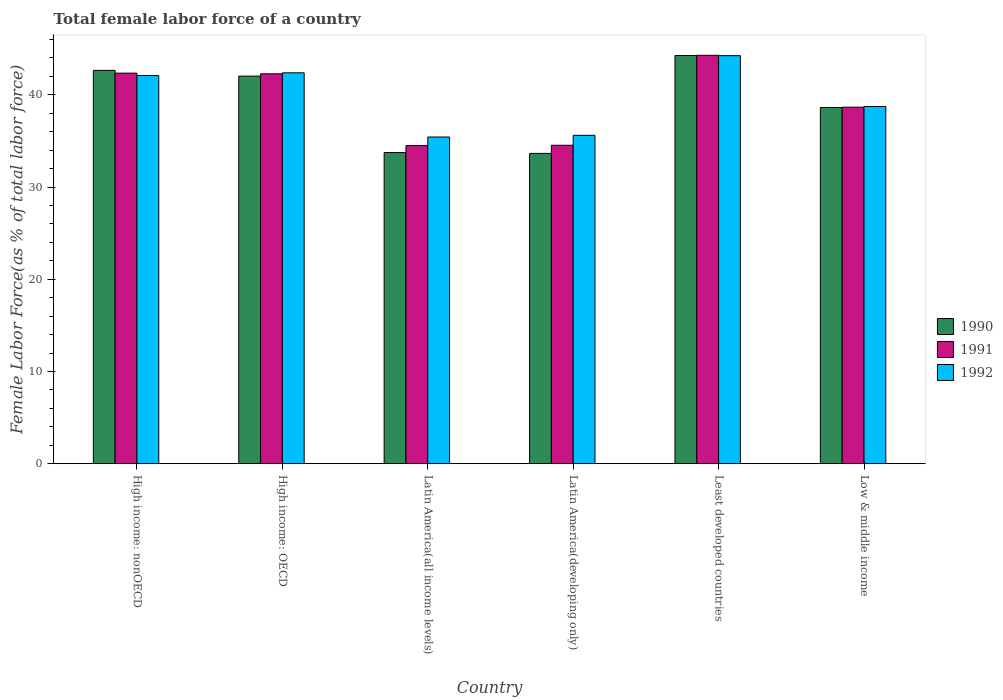How many different coloured bars are there?
Your answer should be compact. 3. Are the number of bars per tick equal to the number of legend labels?
Keep it short and to the point. Yes. Are the number of bars on each tick of the X-axis equal?
Keep it short and to the point. Yes. How many bars are there on the 2nd tick from the right?
Your answer should be very brief. 3. What is the label of the 1st group of bars from the left?
Ensure brevity in your answer.  High income: nonOECD. What is the percentage of female labor force in 1991 in Low & middle income?
Make the answer very short. 38.65. Across all countries, what is the maximum percentage of female labor force in 1990?
Offer a terse response. 44.25. Across all countries, what is the minimum percentage of female labor force in 1992?
Give a very brief answer. 35.42. In which country was the percentage of female labor force in 1990 maximum?
Ensure brevity in your answer.  Least developed countries. In which country was the percentage of female labor force in 1992 minimum?
Keep it short and to the point. Latin America(all income levels). What is the total percentage of female labor force in 1991 in the graph?
Ensure brevity in your answer.  236.56. What is the difference between the percentage of female labor force in 1992 in High income: OECD and that in Least developed countries?
Provide a succinct answer. -1.86. What is the difference between the percentage of female labor force in 1992 in High income: OECD and the percentage of female labor force in 1991 in Latin America(developing only)?
Ensure brevity in your answer.  7.85. What is the average percentage of female labor force in 1991 per country?
Offer a very short reply. 39.43. What is the difference between the percentage of female labor force of/in 1990 and percentage of female labor force of/in 1991 in Least developed countries?
Keep it short and to the point. -0.02. In how many countries, is the percentage of female labor force in 1990 greater than 10 %?
Give a very brief answer. 6. What is the ratio of the percentage of female labor force in 1991 in High income: OECD to that in High income: nonOECD?
Keep it short and to the point. 1. Is the difference between the percentage of female labor force in 1990 in Latin America(all income levels) and Least developed countries greater than the difference between the percentage of female labor force in 1991 in Latin America(all income levels) and Least developed countries?
Give a very brief answer. No. What is the difference between the highest and the second highest percentage of female labor force in 1991?
Give a very brief answer. -1.94. What is the difference between the highest and the lowest percentage of female labor force in 1990?
Provide a succinct answer. 10.61. Is the sum of the percentage of female labor force in 1992 in High income: OECD and High income: nonOECD greater than the maximum percentage of female labor force in 1990 across all countries?
Provide a succinct answer. Yes. What does the 1st bar from the left in Low & middle income represents?
Keep it short and to the point. 1990. Is it the case that in every country, the sum of the percentage of female labor force in 1991 and percentage of female labor force in 1992 is greater than the percentage of female labor force in 1990?
Your answer should be very brief. Yes. Are all the bars in the graph horizontal?
Make the answer very short. No. How many countries are there in the graph?
Ensure brevity in your answer.  6. Where does the legend appear in the graph?
Offer a terse response. Center right. How are the legend labels stacked?
Provide a succinct answer. Vertical. What is the title of the graph?
Your answer should be very brief. Total female labor force of a country. Does "1972" appear as one of the legend labels in the graph?
Make the answer very short. No. What is the label or title of the X-axis?
Make the answer very short. Country. What is the label or title of the Y-axis?
Keep it short and to the point. Female Labor Force(as % of total labor force). What is the Female Labor Force(as % of total labor force) in 1990 in High income: nonOECD?
Your answer should be very brief. 42.64. What is the Female Labor Force(as % of total labor force) of 1991 in High income: nonOECD?
Provide a short and direct response. 42.34. What is the Female Labor Force(as % of total labor force) of 1992 in High income: nonOECD?
Your answer should be very brief. 42.08. What is the Female Labor Force(as % of total labor force) in 1990 in High income: OECD?
Your response must be concise. 42.02. What is the Female Labor Force(as % of total labor force) of 1991 in High income: OECD?
Your answer should be compact. 42.27. What is the Female Labor Force(as % of total labor force) in 1992 in High income: OECD?
Your response must be concise. 42.38. What is the Female Labor Force(as % of total labor force) of 1990 in Latin America(all income levels)?
Make the answer very short. 33.73. What is the Female Labor Force(as % of total labor force) in 1991 in Latin America(all income levels)?
Your answer should be compact. 34.49. What is the Female Labor Force(as % of total labor force) of 1992 in Latin America(all income levels)?
Give a very brief answer. 35.42. What is the Female Labor Force(as % of total labor force) of 1990 in Latin America(developing only)?
Offer a terse response. 33.64. What is the Female Labor Force(as % of total labor force) of 1991 in Latin America(developing only)?
Provide a short and direct response. 34.52. What is the Female Labor Force(as % of total labor force) of 1992 in Latin America(developing only)?
Your answer should be very brief. 35.6. What is the Female Labor Force(as % of total labor force) of 1990 in Least developed countries?
Give a very brief answer. 44.25. What is the Female Labor Force(as % of total labor force) in 1991 in Least developed countries?
Offer a terse response. 44.28. What is the Female Labor Force(as % of total labor force) in 1992 in Least developed countries?
Give a very brief answer. 44.24. What is the Female Labor Force(as % of total labor force) in 1990 in Low & middle income?
Give a very brief answer. 38.62. What is the Female Labor Force(as % of total labor force) in 1991 in Low & middle income?
Offer a terse response. 38.65. What is the Female Labor Force(as % of total labor force) in 1992 in Low & middle income?
Ensure brevity in your answer.  38.73. Across all countries, what is the maximum Female Labor Force(as % of total labor force) in 1990?
Your answer should be very brief. 44.25. Across all countries, what is the maximum Female Labor Force(as % of total labor force) in 1991?
Keep it short and to the point. 44.28. Across all countries, what is the maximum Female Labor Force(as % of total labor force) in 1992?
Ensure brevity in your answer.  44.24. Across all countries, what is the minimum Female Labor Force(as % of total labor force) in 1990?
Offer a very short reply. 33.64. Across all countries, what is the minimum Female Labor Force(as % of total labor force) in 1991?
Offer a terse response. 34.49. Across all countries, what is the minimum Female Labor Force(as % of total labor force) of 1992?
Your answer should be very brief. 35.42. What is the total Female Labor Force(as % of total labor force) of 1990 in the graph?
Provide a succinct answer. 234.91. What is the total Female Labor Force(as % of total labor force) of 1991 in the graph?
Provide a short and direct response. 236.56. What is the total Female Labor Force(as % of total labor force) in 1992 in the graph?
Provide a succinct answer. 238.45. What is the difference between the Female Labor Force(as % of total labor force) of 1990 in High income: nonOECD and that in High income: OECD?
Provide a short and direct response. 0.62. What is the difference between the Female Labor Force(as % of total labor force) in 1991 in High income: nonOECD and that in High income: OECD?
Offer a terse response. 0.07. What is the difference between the Female Labor Force(as % of total labor force) in 1992 in High income: nonOECD and that in High income: OECD?
Make the answer very short. -0.29. What is the difference between the Female Labor Force(as % of total labor force) of 1990 in High income: nonOECD and that in Latin America(all income levels)?
Give a very brief answer. 8.91. What is the difference between the Female Labor Force(as % of total labor force) in 1991 in High income: nonOECD and that in Latin America(all income levels)?
Your response must be concise. 7.85. What is the difference between the Female Labor Force(as % of total labor force) of 1992 in High income: nonOECD and that in Latin America(all income levels)?
Ensure brevity in your answer.  6.66. What is the difference between the Female Labor Force(as % of total labor force) of 1990 in High income: nonOECD and that in Latin America(developing only)?
Provide a succinct answer. 9. What is the difference between the Female Labor Force(as % of total labor force) of 1991 in High income: nonOECD and that in Latin America(developing only)?
Ensure brevity in your answer.  7.82. What is the difference between the Female Labor Force(as % of total labor force) in 1992 in High income: nonOECD and that in Latin America(developing only)?
Offer a terse response. 6.48. What is the difference between the Female Labor Force(as % of total labor force) of 1990 in High income: nonOECD and that in Least developed countries?
Keep it short and to the point. -1.61. What is the difference between the Female Labor Force(as % of total labor force) in 1991 in High income: nonOECD and that in Least developed countries?
Offer a very short reply. -1.94. What is the difference between the Female Labor Force(as % of total labor force) of 1992 in High income: nonOECD and that in Least developed countries?
Offer a terse response. -2.16. What is the difference between the Female Labor Force(as % of total labor force) in 1990 in High income: nonOECD and that in Low & middle income?
Provide a short and direct response. 4.03. What is the difference between the Female Labor Force(as % of total labor force) of 1991 in High income: nonOECD and that in Low & middle income?
Your answer should be compact. 3.69. What is the difference between the Female Labor Force(as % of total labor force) in 1992 in High income: nonOECD and that in Low & middle income?
Your response must be concise. 3.35. What is the difference between the Female Labor Force(as % of total labor force) of 1990 in High income: OECD and that in Latin America(all income levels)?
Your answer should be very brief. 8.29. What is the difference between the Female Labor Force(as % of total labor force) in 1991 in High income: OECD and that in Latin America(all income levels)?
Offer a very short reply. 7.78. What is the difference between the Female Labor Force(as % of total labor force) in 1992 in High income: OECD and that in Latin America(all income levels)?
Give a very brief answer. 6.96. What is the difference between the Female Labor Force(as % of total labor force) of 1990 in High income: OECD and that in Latin America(developing only)?
Provide a succinct answer. 8.38. What is the difference between the Female Labor Force(as % of total labor force) of 1991 in High income: OECD and that in Latin America(developing only)?
Provide a succinct answer. 7.75. What is the difference between the Female Labor Force(as % of total labor force) of 1992 in High income: OECD and that in Latin America(developing only)?
Give a very brief answer. 6.77. What is the difference between the Female Labor Force(as % of total labor force) in 1990 in High income: OECD and that in Least developed countries?
Give a very brief answer. -2.23. What is the difference between the Female Labor Force(as % of total labor force) in 1991 in High income: OECD and that in Least developed countries?
Give a very brief answer. -2.01. What is the difference between the Female Labor Force(as % of total labor force) in 1992 in High income: OECD and that in Least developed countries?
Offer a very short reply. -1.86. What is the difference between the Female Labor Force(as % of total labor force) in 1990 in High income: OECD and that in Low & middle income?
Keep it short and to the point. 3.4. What is the difference between the Female Labor Force(as % of total labor force) in 1991 in High income: OECD and that in Low & middle income?
Provide a short and direct response. 3.62. What is the difference between the Female Labor Force(as % of total labor force) of 1992 in High income: OECD and that in Low & middle income?
Ensure brevity in your answer.  3.65. What is the difference between the Female Labor Force(as % of total labor force) in 1990 in Latin America(all income levels) and that in Latin America(developing only)?
Keep it short and to the point. 0.09. What is the difference between the Female Labor Force(as % of total labor force) of 1991 in Latin America(all income levels) and that in Latin America(developing only)?
Give a very brief answer. -0.03. What is the difference between the Female Labor Force(as % of total labor force) in 1992 in Latin America(all income levels) and that in Latin America(developing only)?
Offer a very short reply. -0.18. What is the difference between the Female Labor Force(as % of total labor force) in 1990 in Latin America(all income levels) and that in Least developed countries?
Ensure brevity in your answer.  -10.52. What is the difference between the Female Labor Force(as % of total labor force) of 1991 in Latin America(all income levels) and that in Least developed countries?
Make the answer very short. -9.79. What is the difference between the Female Labor Force(as % of total labor force) in 1992 in Latin America(all income levels) and that in Least developed countries?
Offer a terse response. -8.82. What is the difference between the Female Labor Force(as % of total labor force) of 1990 in Latin America(all income levels) and that in Low & middle income?
Provide a short and direct response. -4.88. What is the difference between the Female Labor Force(as % of total labor force) in 1991 in Latin America(all income levels) and that in Low & middle income?
Your answer should be compact. -4.16. What is the difference between the Female Labor Force(as % of total labor force) of 1992 in Latin America(all income levels) and that in Low & middle income?
Offer a very short reply. -3.31. What is the difference between the Female Labor Force(as % of total labor force) of 1990 in Latin America(developing only) and that in Least developed countries?
Ensure brevity in your answer.  -10.61. What is the difference between the Female Labor Force(as % of total labor force) of 1991 in Latin America(developing only) and that in Least developed countries?
Your response must be concise. -9.75. What is the difference between the Female Labor Force(as % of total labor force) in 1992 in Latin America(developing only) and that in Least developed countries?
Give a very brief answer. -8.63. What is the difference between the Female Labor Force(as % of total labor force) of 1990 in Latin America(developing only) and that in Low & middle income?
Your answer should be very brief. -4.97. What is the difference between the Female Labor Force(as % of total labor force) in 1991 in Latin America(developing only) and that in Low & middle income?
Offer a very short reply. -4.13. What is the difference between the Female Labor Force(as % of total labor force) of 1992 in Latin America(developing only) and that in Low & middle income?
Keep it short and to the point. -3.12. What is the difference between the Female Labor Force(as % of total labor force) in 1990 in Least developed countries and that in Low & middle income?
Provide a succinct answer. 5.64. What is the difference between the Female Labor Force(as % of total labor force) in 1991 in Least developed countries and that in Low & middle income?
Ensure brevity in your answer.  5.62. What is the difference between the Female Labor Force(as % of total labor force) in 1992 in Least developed countries and that in Low & middle income?
Your answer should be very brief. 5.51. What is the difference between the Female Labor Force(as % of total labor force) in 1990 in High income: nonOECD and the Female Labor Force(as % of total labor force) in 1991 in High income: OECD?
Your response must be concise. 0.37. What is the difference between the Female Labor Force(as % of total labor force) in 1990 in High income: nonOECD and the Female Labor Force(as % of total labor force) in 1992 in High income: OECD?
Your answer should be compact. 0.27. What is the difference between the Female Labor Force(as % of total labor force) of 1991 in High income: nonOECD and the Female Labor Force(as % of total labor force) of 1992 in High income: OECD?
Give a very brief answer. -0.04. What is the difference between the Female Labor Force(as % of total labor force) in 1990 in High income: nonOECD and the Female Labor Force(as % of total labor force) in 1991 in Latin America(all income levels)?
Your answer should be very brief. 8.15. What is the difference between the Female Labor Force(as % of total labor force) of 1990 in High income: nonOECD and the Female Labor Force(as % of total labor force) of 1992 in Latin America(all income levels)?
Provide a succinct answer. 7.22. What is the difference between the Female Labor Force(as % of total labor force) in 1991 in High income: nonOECD and the Female Labor Force(as % of total labor force) in 1992 in Latin America(all income levels)?
Offer a very short reply. 6.92. What is the difference between the Female Labor Force(as % of total labor force) in 1990 in High income: nonOECD and the Female Labor Force(as % of total labor force) in 1991 in Latin America(developing only)?
Your response must be concise. 8.12. What is the difference between the Female Labor Force(as % of total labor force) of 1990 in High income: nonOECD and the Female Labor Force(as % of total labor force) of 1992 in Latin America(developing only)?
Your response must be concise. 7.04. What is the difference between the Female Labor Force(as % of total labor force) in 1991 in High income: nonOECD and the Female Labor Force(as % of total labor force) in 1992 in Latin America(developing only)?
Offer a terse response. 6.74. What is the difference between the Female Labor Force(as % of total labor force) in 1990 in High income: nonOECD and the Female Labor Force(as % of total labor force) in 1991 in Least developed countries?
Your response must be concise. -1.63. What is the difference between the Female Labor Force(as % of total labor force) in 1990 in High income: nonOECD and the Female Labor Force(as % of total labor force) in 1992 in Least developed countries?
Ensure brevity in your answer.  -1.6. What is the difference between the Female Labor Force(as % of total labor force) in 1991 in High income: nonOECD and the Female Labor Force(as % of total labor force) in 1992 in Least developed countries?
Your answer should be very brief. -1.9. What is the difference between the Female Labor Force(as % of total labor force) of 1990 in High income: nonOECD and the Female Labor Force(as % of total labor force) of 1991 in Low & middle income?
Ensure brevity in your answer.  3.99. What is the difference between the Female Labor Force(as % of total labor force) of 1990 in High income: nonOECD and the Female Labor Force(as % of total labor force) of 1992 in Low & middle income?
Provide a succinct answer. 3.91. What is the difference between the Female Labor Force(as % of total labor force) in 1991 in High income: nonOECD and the Female Labor Force(as % of total labor force) in 1992 in Low & middle income?
Your response must be concise. 3.61. What is the difference between the Female Labor Force(as % of total labor force) of 1990 in High income: OECD and the Female Labor Force(as % of total labor force) of 1991 in Latin America(all income levels)?
Your answer should be very brief. 7.53. What is the difference between the Female Labor Force(as % of total labor force) of 1990 in High income: OECD and the Female Labor Force(as % of total labor force) of 1992 in Latin America(all income levels)?
Ensure brevity in your answer.  6.6. What is the difference between the Female Labor Force(as % of total labor force) of 1991 in High income: OECD and the Female Labor Force(as % of total labor force) of 1992 in Latin America(all income levels)?
Offer a terse response. 6.85. What is the difference between the Female Labor Force(as % of total labor force) in 1990 in High income: OECD and the Female Labor Force(as % of total labor force) in 1991 in Latin America(developing only)?
Provide a short and direct response. 7.5. What is the difference between the Female Labor Force(as % of total labor force) in 1990 in High income: OECD and the Female Labor Force(as % of total labor force) in 1992 in Latin America(developing only)?
Provide a succinct answer. 6.42. What is the difference between the Female Labor Force(as % of total labor force) of 1991 in High income: OECD and the Female Labor Force(as % of total labor force) of 1992 in Latin America(developing only)?
Keep it short and to the point. 6.67. What is the difference between the Female Labor Force(as % of total labor force) in 1990 in High income: OECD and the Female Labor Force(as % of total labor force) in 1991 in Least developed countries?
Make the answer very short. -2.26. What is the difference between the Female Labor Force(as % of total labor force) of 1990 in High income: OECD and the Female Labor Force(as % of total labor force) of 1992 in Least developed countries?
Your answer should be compact. -2.22. What is the difference between the Female Labor Force(as % of total labor force) in 1991 in High income: OECD and the Female Labor Force(as % of total labor force) in 1992 in Least developed countries?
Your answer should be compact. -1.97. What is the difference between the Female Labor Force(as % of total labor force) in 1990 in High income: OECD and the Female Labor Force(as % of total labor force) in 1991 in Low & middle income?
Offer a terse response. 3.37. What is the difference between the Female Labor Force(as % of total labor force) of 1990 in High income: OECD and the Female Labor Force(as % of total labor force) of 1992 in Low & middle income?
Your response must be concise. 3.29. What is the difference between the Female Labor Force(as % of total labor force) of 1991 in High income: OECD and the Female Labor Force(as % of total labor force) of 1992 in Low & middle income?
Provide a short and direct response. 3.54. What is the difference between the Female Labor Force(as % of total labor force) of 1990 in Latin America(all income levels) and the Female Labor Force(as % of total labor force) of 1991 in Latin America(developing only)?
Offer a very short reply. -0.79. What is the difference between the Female Labor Force(as % of total labor force) of 1990 in Latin America(all income levels) and the Female Labor Force(as % of total labor force) of 1992 in Latin America(developing only)?
Ensure brevity in your answer.  -1.87. What is the difference between the Female Labor Force(as % of total labor force) in 1991 in Latin America(all income levels) and the Female Labor Force(as % of total labor force) in 1992 in Latin America(developing only)?
Your answer should be very brief. -1.11. What is the difference between the Female Labor Force(as % of total labor force) of 1990 in Latin America(all income levels) and the Female Labor Force(as % of total labor force) of 1991 in Least developed countries?
Ensure brevity in your answer.  -10.55. What is the difference between the Female Labor Force(as % of total labor force) in 1990 in Latin America(all income levels) and the Female Labor Force(as % of total labor force) in 1992 in Least developed countries?
Your answer should be compact. -10.51. What is the difference between the Female Labor Force(as % of total labor force) in 1991 in Latin America(all income levels) and the Female Labor Force(as % of total labor force) in 1992 in Least developed countries?
Give a very brief answer. -9.75. What is the difference between the Female Labor Force(as % of total labor force) in 1990 in Latin America(all income levels) and the Female Labor Force(as % of total labor force) in 1991 in Low & middle income?
Keep it short and to the point. -4.92. What is the difference between the Female Labor Force(as % of total labor force) in 1990 in Latin America(all income levels) and the Female Labor Force(as % of total labor force) in 1992 in Low & middle income?
Offer a terse response. -5. What is the difference between the Female Labor Force(as % of total labor force) in 1991 in Latin America(all income levels) and the Female Labor Force(as % of total labor force) in 1992 in Low & middle income?
Your answer should be compact. -4.24. What is the difference between the Female Labor Force(as % of total labor force) in 1990 in Latin America(developing only) and the Female Labor Force(as % of total labor force) in 1991 in Least developed countries?
Make the answer very short. -10.63. What is the difference between the Female Labor Force(as % of total labor force) of 1990 in Latin America(developing only) and the Female Labor Force(as % of total labor force) of 1992 in Least developed countries?
Your response must be concise. -10.6. What is the difference between the Female Labor Force(as % of total labor force) in 1991 in Latin America(developing only) and the Female Labor Force(as % of total labor force) in 1992 in Least developed countries?
Make the answer very short. -9.72. What is the difference between the Female Labor Force(as % of total labor force) in 1990 in Latin America(developing only) and the Female Labor Force(as % of total labor force) in 1991 in Low & middle income?
Your answer should be very brief. -5.01. What is the difference between the Female Labor Force(as % of total labor force) of 1990 in Latin America(developing only) and the Female Labor Force(as % of total labor force) of 1992 in Low & middle income?
Keep it short and to the point. -5.09. What is the difference between the Female Labor Force(as % of total labor force) of 1991 in Latin America(developing only) and the Female Labor Force(as % of total labor force) of 1992 in Low & middle income?
Ensure brevity in your answer.  -4.21. What is the difference between the Female Labor Force(as % of total labor force) in 1990 in Least developed countries and the Female Labor Force(as % of total labor force) in 1991 in Low & middle income?
Offer a terse response. 5.6. What is the difference between the Female Labor Force(as % of total labor force) in 1990 in Least developed countries and the Female Labor Force(as % of total labor force) in 1992 in Low & middle income?
Your answer should be very brief. 5.53. What is the difference between the Female Labor Force(as % of total labor force) of 1991 in Least developed countries and the Female Labor Force(as % of total labor force) of 1992 in Low & middle income?
Your answer should be compact. 5.55. What is the average Female Labor Force(as % of total labor force) in 1990 per country?
Give a very brief answer. 39.15. What is the average Female Labor Force(as % of total labor force) of 1991 per country?
Your answer should be compact. 39.43. What is the average Female Labor Force(as % of total labor force) of 1992 per country?
Make the answer very short. 39.74. What is the difference between the Female Labor Force(as % of total labor force) of 1990 and Female Labor Force(as % of total labor force) of 1991 in High income: nonOECD?
Keep it short and to the point. 0.3. What is the difference between the Female Labor Force(as % of total labor force) in 1990 and Female Labor Force(as % of total labor force) in 1992 in High income: nonOECD?
Ensure brevity in your answer.  0.56. What is the difference between the Female Labor Force(as % of total labor force) of 1991 and Female Labor Force(as % of total labor force) of 1992 in High income: nonOECD?
Keep it short and to the point. 0.26. What is the difference between the Female Labor Force(as % of total labor force) in 1990 and Female Labor Force(as % of total labor force) in 1991 in High income: OECD?
Offer a very short reply. -0.25. What is the difference between the Female Labor Force(as % of total labor force) of 1990 and Female Labor Force(as % of total labor force) of 1992 in High income: OECD?
Offer a terse response. -0.36. What is the difference between the Female Labor Force(as % of total labor force) of 1991 and Female Labor Force(as % of total labor force) of 1992 in High income: OECD?
Give a very brief answer. -0.11. What is the difference between the Female Labor Force(as % of total labor force) of 1990 and Female Labor Force(as % of total labor force) of 1991 in Latin America(all income levels)?
Your response must be concise. -0.76. What is the difference between the Female Labor Force(as % of total labor force) in 1990 and Female Labor Force(as % of total labor force) in 1992 in Latin America(all income levels)?
Offer a very short reply. -1.69. What is the difference between the Female Labor Force(as % of total labor force) of 1991 and Female Labor Force(as % of total labor force) of 1992 in Latin America(all income levels)?
Provide a succinct answer. -0.93. What is the difference between the Female Labor Force(as % of total labor force) in 1990 and Female Labor Force(as % of total labor force) in 1991 in Latin America(developing only)?
Give a very brief answer. -0.88. What is the difference between the Female Labor Force(as % of total labor force) in 1990 and Female Labor Force(as % of total labor force) in 1992 in Latin America(developing only)?
Your answer should be compact. -1.96. What is the difference between the Female Labor Force(as % of total labor force) in 1991 and Female Labor Force(as % of total labor force) in 1992 in Latin America(developing only)?
Ensure brevity in your answer.  -1.08. What is the difference between the Female Labor Force(as % of total labor force) in 1990 and Female Labor Force(as % of total labor force) in 1991 in Least developed countries?
Make the answer very short. -0.02. What is the difference between the Female Labor Force(as % of total labor force) in 1990 and Female Labor Force(as % of total labor force) in 1992 in Least developed countries?
Offer a terse response. 0.01. What is the difference between the Female Labor Force(as % of total labor force) in 1991 and Female Labor Force(as % of total labor force) in 1992 in Least developed countries?
Offer a terse response. 0.04. What is the difference between the Female Labor Force(as % of total labor force) of 1990 and Female Labor Force(as % of total labor force) of 1991 in Low & middle income?
Your response must be concise. -0.04. What is the difference between the Female Labor Force(as % of total labor force) in 1990 and Female Labor Force(as % of total labor force) in 1992 in Low & middle income?
Offer a terse response. -0.11. What is the difference between the Female Labor Force(as % of total labor force) in 1991 and Female Labor Force(as % of total labor force) in 1992 in Low & middle income?
Your response must be concise. -0.07. What is the ratio of the Female Labor Force(as % of total labor force) in 1990 in High income: nonOECD to that in High income: OECD?
Your response must be concise. 1.01. What is the ratio of the Female Labor Force(as % of total labor force) in 1992 in High income: nonOECD to that in High income: OECD?
Offer a terse response. 0.99. What is the ratio of the Female Labor Force(as % of total labor force) in 1990 in High income: nonOECD to that in Latin America(all income levels)?
Provide a succinct answer. 1.26. What is the ratio of the Female Labor Force(as % of total labor force) in 1991 in High income: nonOECD to that in Latin America(all income levels)?
Make the answer very short. 1.23. What is the ratio of the Female Labor Force(as % of total labor force) in 1992 in High income: nonOECD to that in Latin America(all income levels)?
Offer a very short reply. 1.19. What is the ratio of the Female Labor Force(as % of total labor force) in 1990 in High income: nonOECD to that in Latin America(developing only)?
Your answer should be compact. 1.27. What is the ratio of the Female Labor Force(as % of total labor force) of 1991 in High income: nonOECD to that in Latin America(developing only)?
Your response must be concise. 1.23. What is the ratio of the Female Labor Force(as % of total labor force) in 1992 in High income: nonOECD to that in Latin America(developing only)?
Provide a succinct answer. 1.18. What is the ratio of the Female Labor Force(as % of total labor force) of 1990 in High income: nonOECD to that in Least developed countries?
Keep it short and to the point. 0.96. What is the ratio of the Female Labor Force(as % of total labor force) of 1991 in High income: nonOECD to that in Least developed countries?
Ensure brevity in your answer.  0.96. What is the ratio of the Female Labor Force(as % of total labor force) in 1992 in High income: nonOECD to that in Least developed countries?
Provide a succinct answer. 0.95. What is the ratio of the Female Labor Force(as % of total labor force) of 1990 in High income: nonOECD to that in Low & middle income?
Your response must be concise. 1.1. What is the ratio of the Female Labor Force(as % of total labor force) in 1991 in High income: nonOECD to that in Low & middle income?
Provide a short and direct response. 1.1. What is the ratio of the Female Labor Force(as % of total labor force) of 1992 in High income: nonOECD to that in Low & middle income?
Offer a very short reply. 1.09. What is the ratio of the Female Labor Force(as % of total labor force) of 1990 in High income: OECD to that in Latin America(all income levels)?
Offer a very short reply. 1.25. What is the ratio of the Female Labor Force(as % of total labor force) of 1991 in High income: OECD to that in Latin America(all income levels)?
Give a very brief answer. 1.23. What is the ratio of the Female Labor Force(as % of total labor force) in 1992 in High income: OECD to that in Latin America(all income levels)?
Your answer should be compact. 1.2. What is the ratio of the Female Labor Force(as % of total labor force) of 1990 in High income: OECD to that in Latin America(developing only)?
Provide a succinct answer. 1.25. What is the ratio of the Female Labor Force(as % of total labor force) in 1991 in High income: OECD to that in Latin America(developing only)?
Your answer should be compact. 1.22. What is the ratio of the Female Labor Force(as % of total labor force) of 1992 in High income: OECD to that in Latin America(developing only)?
Keep it short and to the point. 1.19. What is the ratio of the Female Labor Force(as % of total labor force) of 1990 in High income: OECD to that in Least developed countries?
Ensure brevity in your answer.  0.95. What is the ratio of the Female Labor Force(as % of total labor force) in 1991 in High income: OECD to that in Least developed countries?
Provide a succinct answer. 0.95. What is the ratio of the Female Labor Force(as % of total labor force) of 1992 in High income: OECD to that in Least developed countries?
Your answer should be compact. 0.96. What is the ratio of the Female Labor Force(as % of total labor force) of 1990 in High income: OECD to that in Low & middle income?
Provide a succinct answer. 1.09. What is the ratio of the Female Labor Force(as % of total labor force) in 1991 in High income: OECD to that in Low & middle income?
Provide a short and direct response. 1.09. What is the ratio of the Female Labor Force(as % of total labor force) in 1992 in High income: OECD to that in Low & middle income?
Offer a very short reply. 1.09. What is the ratio of the Female Labor Force(as % of total labor force) in 1990 in Latin America(all income levels) to that in Latin America(developing only)?
Offer a very short reply. 1. What is the ratio of the Female Labor Force(as % of total labor force) in 1991 in Latin America(all income levels) to that in Latin America(developing only)?
Provide a short and direct response. 1. What is the ratio of the Female Labor Force(as % of total labor force) of 1992 in Latin America(all income levels) to that in Latin America(developing only)?
Offer a terse response. 0.99. What is the ratio of the Female Labor Force(as % of total labor force) in 1990 in Latin America(all income levels) to that in Least developed countries?
Provide a succinct answer. 0.76. What is the ratio of the Female Labor Force(as % of total labor force) of 1991 in Latin America(all income levels) to that in Least developed countries?
Your answer should be compact. 0.78. What is the ratio of the Female Labor Force(as % of total labor force) in 1992 in Latin America(all income levels) to that in Least developed countries?
Provide a short and direct response. 0.8. What is the ratio of the Female Labor Force(as % of total labor force) in 1990 in Latin America(all income levels) to that in Low & middle income?
Provide a succinct answer. 0.87. What is the ratio of the Female Labor Force(as % of total labor force) in 1991 in Latin America(all income levels) to that in Low & middle income?
Make the answer very short. 0.89. What is the ratio of the Female Labor Force(as % of total labor force) of 1992 in Latin America(all income levels) to that in Low & middle income?
Provide a succinct answer. 0.91. What is the ratio of the Female Labor Force(as % of total labor force) of 1990 in Latin America(developing only) to that in Least developed countries?
Offer a terse response. 0.76. What is the ratio of the Female Labor Force(as % of total labor force) of 1991 in Latin America(developing only) to that in Least developed countries?
Keep it short and to the point. 0.78. What is the ratio of the Female Labor Force(as % of total labor force) in 1992 in Latin America(developing only) to that in Least developed countries?
Make the answer very short. 0.8. What is the ratio of the Female Labor Force(as % of total labor force) in 1990 in Latin America(developing only) to that in Low & middle income?
Offer a terse response. 0.87. What is the ratio of the Female Labor Force(as % of total labor force) of 1991 in Latin America(developing only) to that in Low & middle income?
Give a very brief answer. 0.89. What is the ratio of the Female Labor Force(as % of total labor force) in 1992 in Latin America(developing only) to that in Low & middle income?
Provide a succinct answer. 0.92. What is the ratio of the Female Labor Force(as % of total labor force) in 1990 in Least developed countries to that in Low & middle income?
Your response must be concise. 1.15. What is the ratio of the Female Labor Force(as % of total labor force) in 1991 in Least developed countries to that in Low & middle income?
Provide a short and direct response. 1.15. What is the ratio of the Female Labor Force(as % of total labor force) in 1992 in Least developed countries to that in Low & middle income?
Make the answer very short. 1.14. What is the difference between the highest and the second highest Female Labor Force(as % of total labor force) in 1990?
Ensure brevity in your answer.  1.61. What is the difference between the highest and the second highest Female Labor Force(as % of total labor force) in 1991?
Your answer should be compact. 1.94. What is the difference between the highest and the second highest Female Labor Force(as % of total labor force) in 1992?
Give a very brief answer. 1.86. What is the difference between the highest and the lowest Female Labor Force(as % of total labor force) in 1990?
Provide a short and direct response. 10.61. What is the difference between the highest and the lowest Female Labor Force(as % of total labor force) of 1991?
Your answer should be compact. 9.79. What is the difference between the highest and the lowest Female Labor Force(as % of total labor force) in 1992?
Keep it short and to the point. 8.82. 